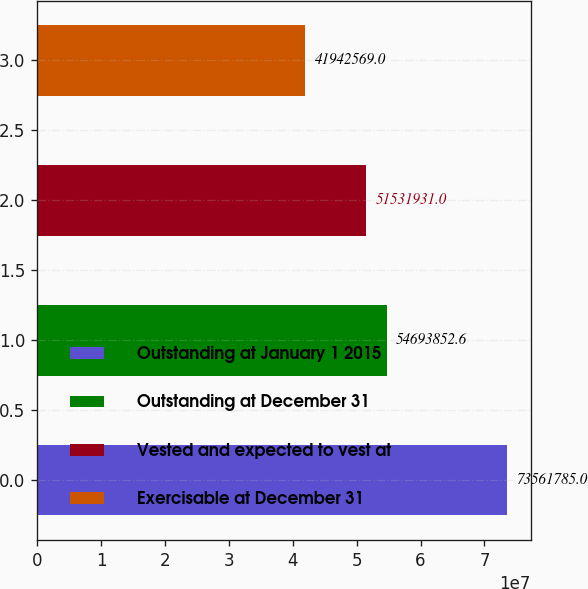Convert chart to OTSL. <chart><loc_0><loc_0><loc_500><loc_500><bar_chart><fcel>Outstanding at January 1 2015<fcel>Outstanding at December 31<fcel>Vested and expected to vest at<fcel>Exercisable at December 31<nl><fcel>7.35618e+07<fcel>5.46939e+07<fcel>5.15319e+07<fcel>4.19426e+07<nl></chart> 